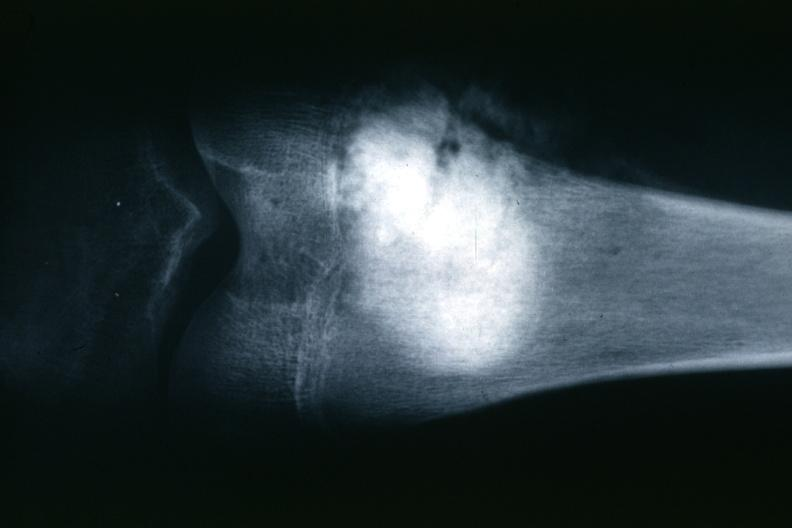does this image show x-ray typical lesion?
Answer the question using a single word or phrase. Yes 